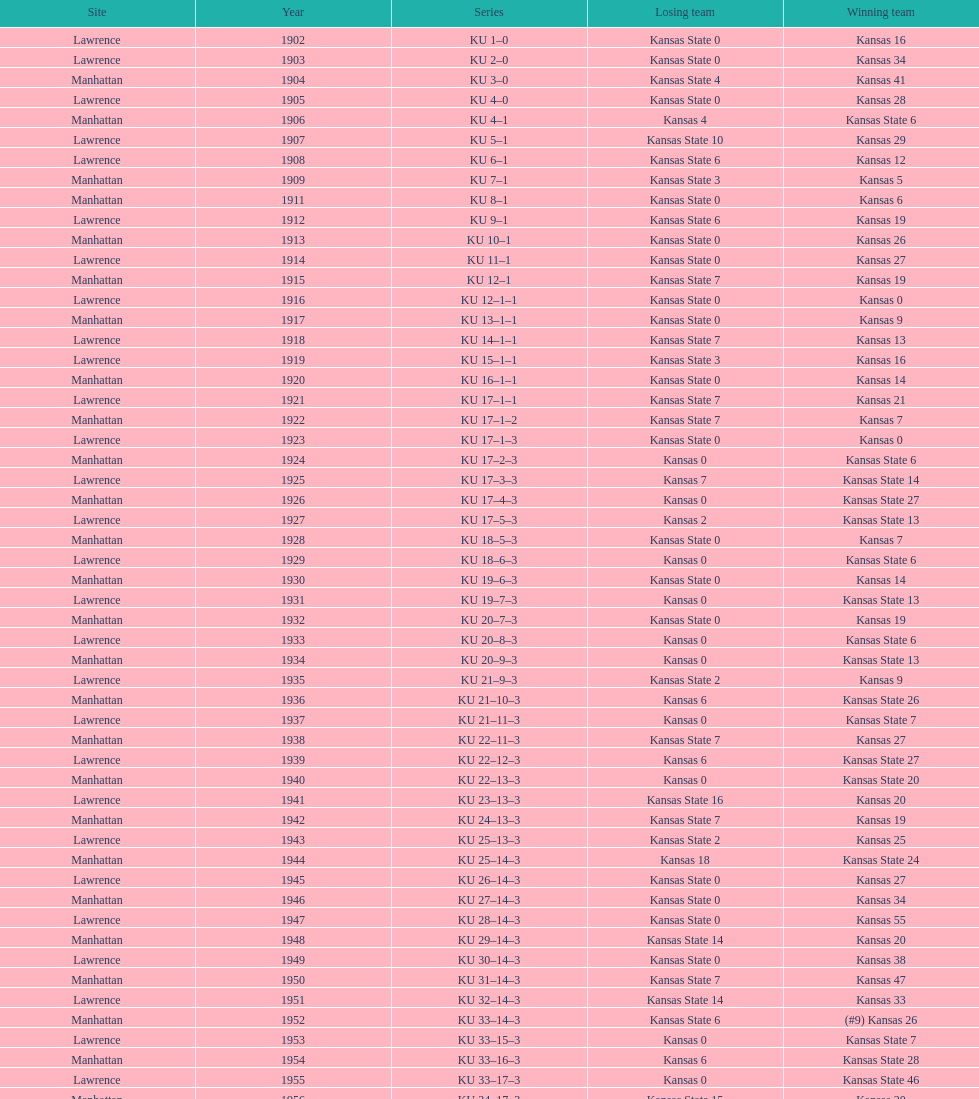What was the number of wins kansas state had in manhattan? 8. 